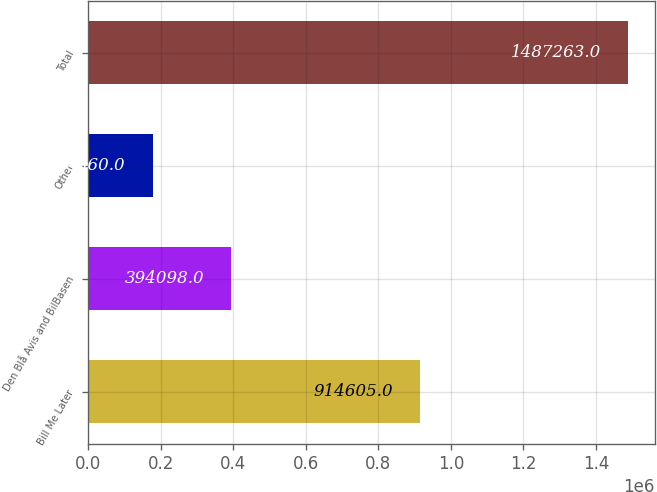Convert chart. <chart><loc_0><loc_0><loc_500><loc_500><bar_chart><fcel>Bill Me Later<fcel>Den Blå Avis and BilBasen<fcel>Other<fcel>Total<nl><fcel>914605<fcel>394098<fcel>178560<fcel>1.48726e+06<nl></chart> 